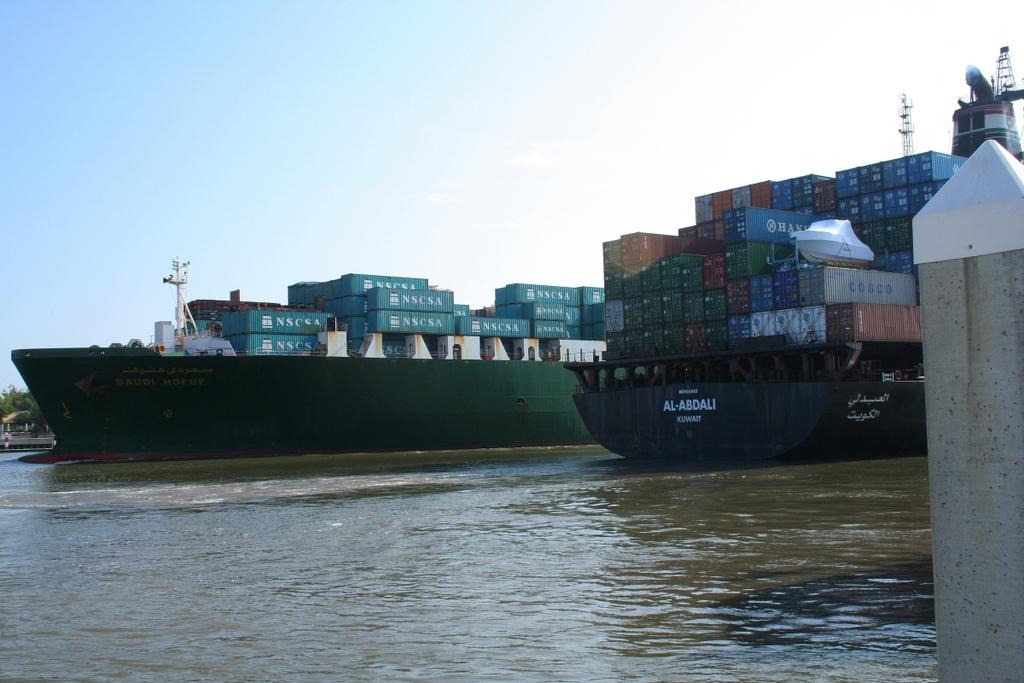<image>
Relay a brief, clear account of the picture shown. A cargo ship carries many stacked blue containers labeled NSCSA. 